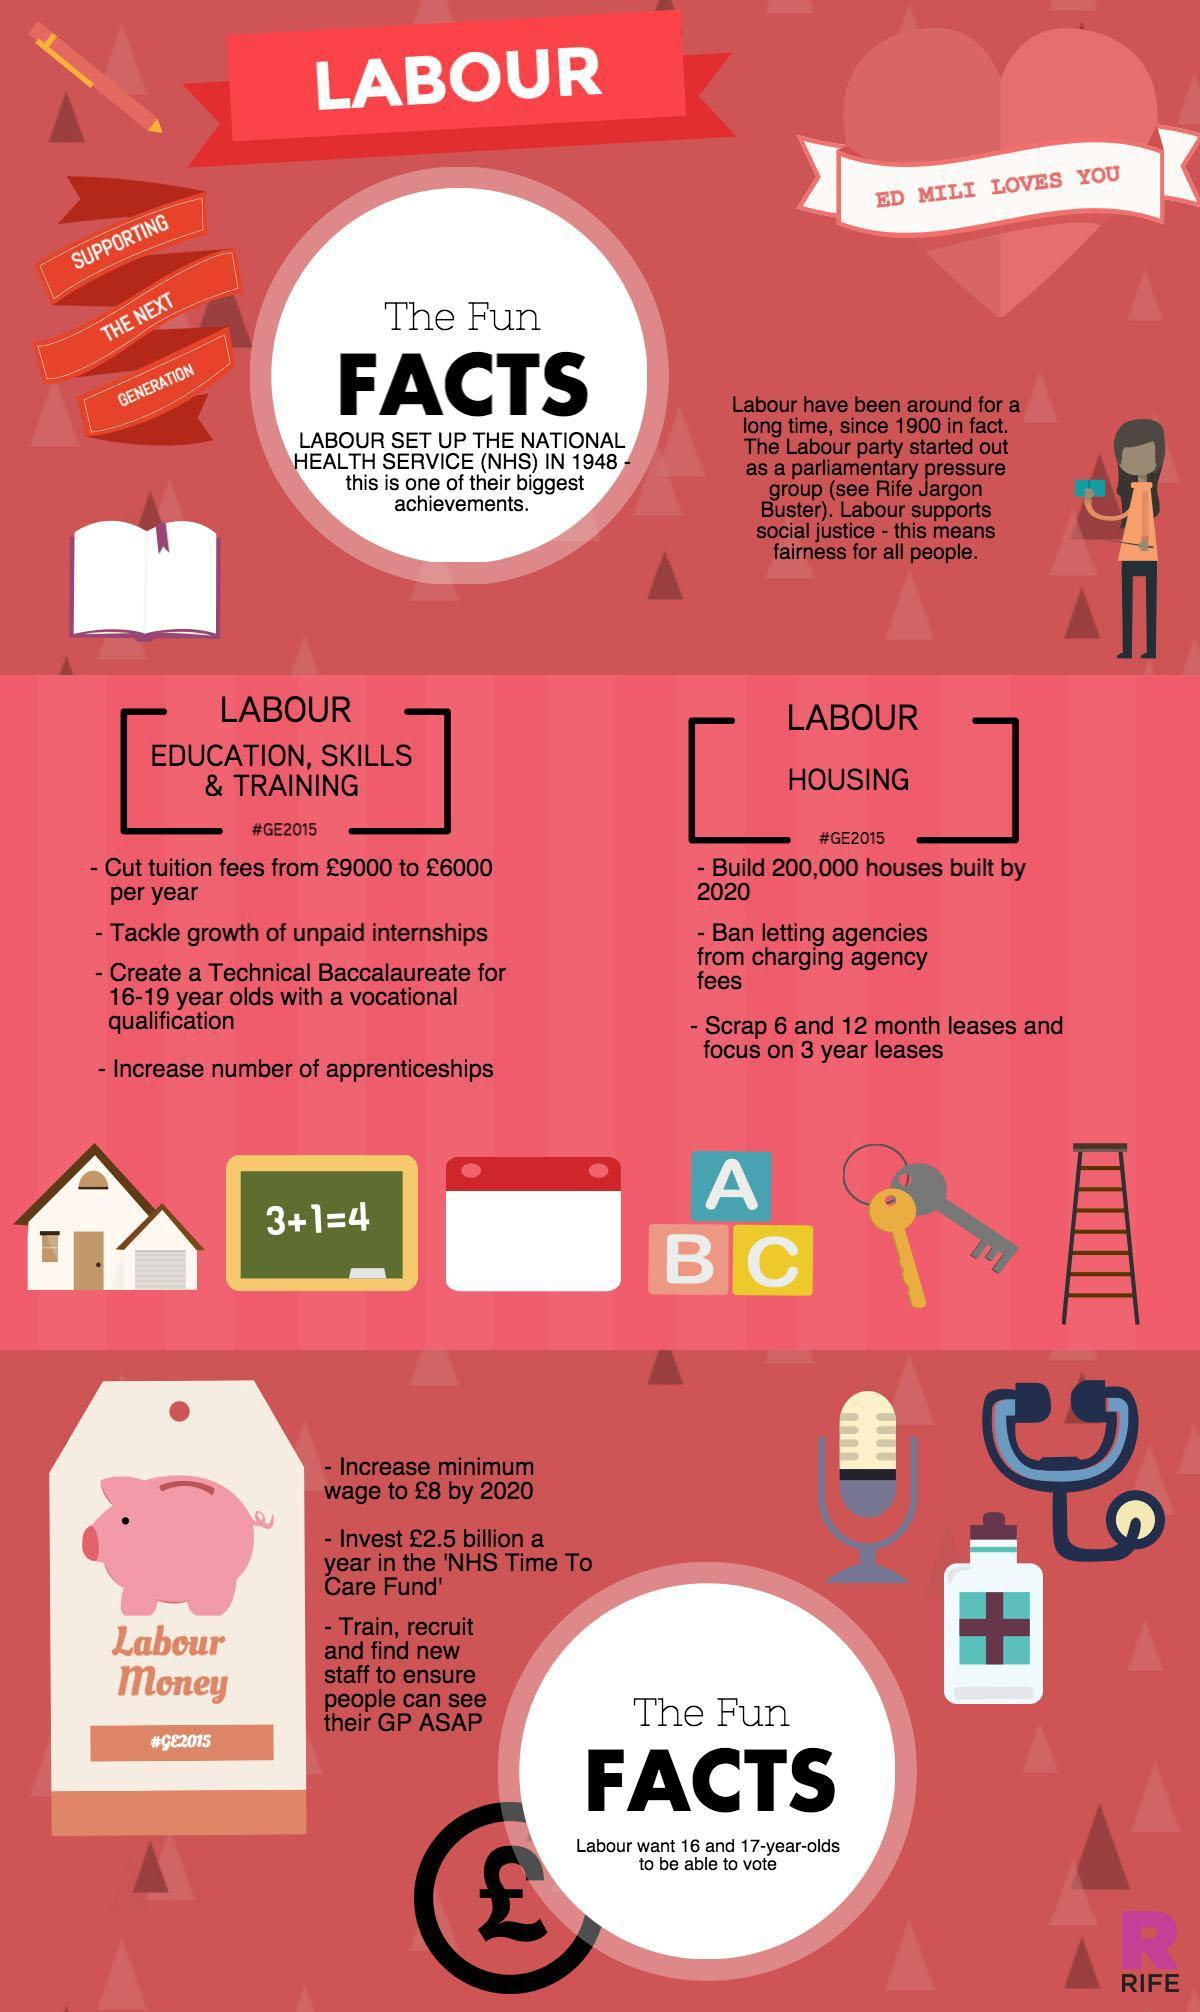How many points are listed under the heading "Labour Housing"?
Answer the question with a short phrase. 3 Which is the word written in biggest font in the infographic? FACTS 